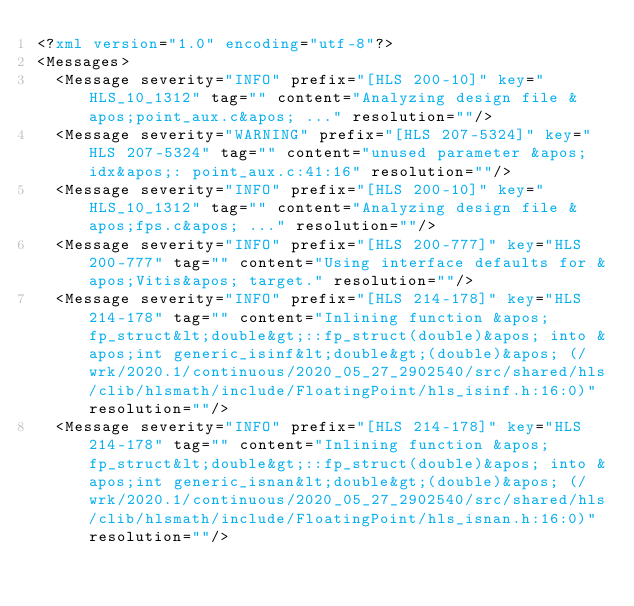Convert code to text. <code><loc_0><loc_0><loc_500><loc_500><_XML_><?xml version="1.0" encoding="utf-8"?>
<Messages>
	<Message severity="INFO" prefix="[HLS 200-10]" key="HLS_10_1312" tag="" content="Analyzing design file &apos;point_aux.c&apos; ..." resolution=""/>
	<Message severity="WARNING" prefix="[HLS 207-5324]" key="HLS 207-5324" tag="" content="unused parameter &apos;idx&apos;: point_aux.c:41:16" resolution=""/>
	<Message severity="INFO" prefix="[HLS 200-10]" key="HLS_10_1312" tag="" content="Analyzing design file &apos;fps.c&apos; ..." resolution=""/>
	<Message severity="INFO" prefix="[HLS 200-777]" key="HLS 200-777" tag="" content="Using interface defaults for &apos;Vitis&apos; target." resolution=""/>
	<Message severity="INFO" prefix="[HLS 214-178]" key="HLS 214-178" tag="" content="Inlining function &apos;fp_struct&lt;double&gt;::fp_struct(double)&apos; into &apos;int generic_isinf&lt;double&gt;(double)&apos; (/wrk/2020.1/continuous/2020_05_27_2902540/src/shared/hls/clib/hlsmath/include/FloatingPoint/hls_isinf.h:16:0)" resolution=""/>
	<Message severity="INFO" prefix="[HLS 214-178]" key="HLS 214-178" tag="" content="Inlining function &apos;fp_struct&lt;double&gt;::fp_struct(double)&apos; into &apos;int generic_isnan&lt;double&gt;(double)&apos; (/wrk/2020.1/continuous/2020_05_27_2902540/src/shared/hls/clib/hlsmath/include/FloatingPoint/hls_isnan.h:16:0)" resolution=""/></code> 